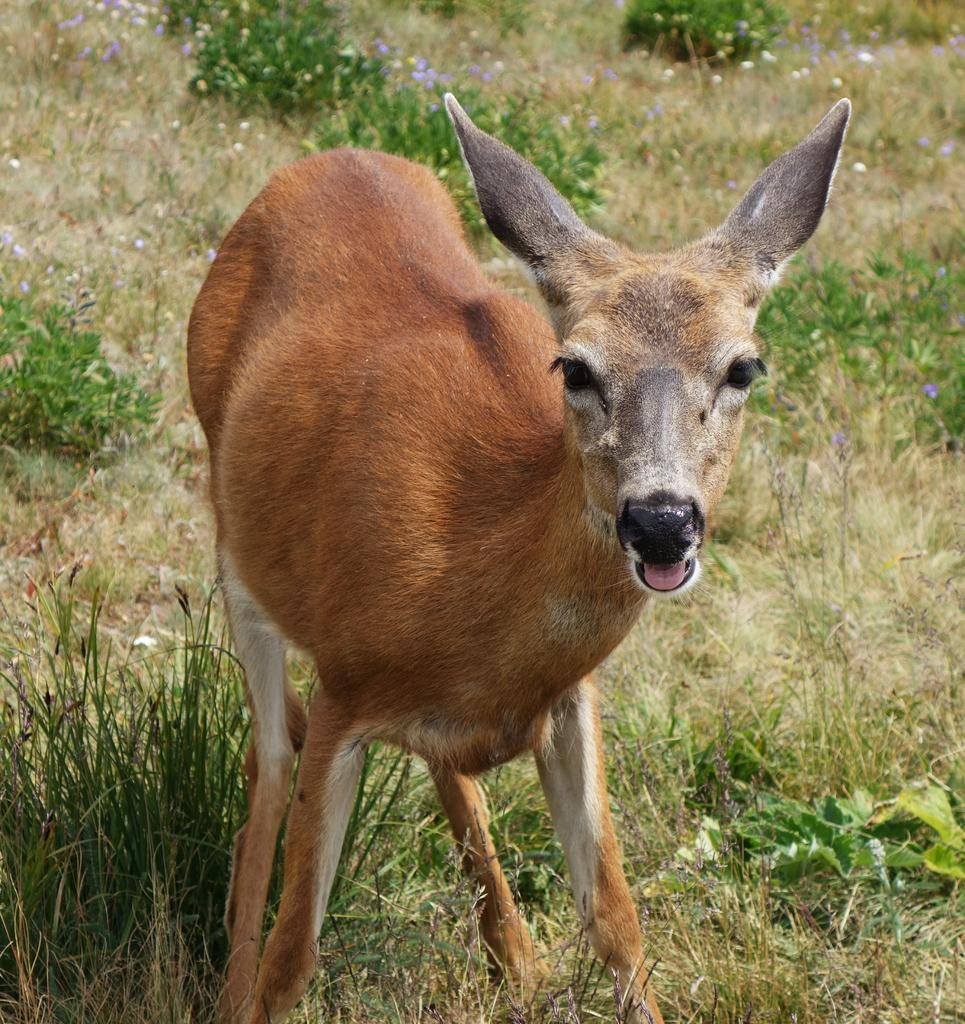What animal is in the foreground of the image? There is a deer in the foreground of the image. What type of environment is the deer in? The deer is on a grassland. What can be seen in the background of the image? There are small flower plants and the grassland visible in the background. What type of leather is being used to make the books in the image? There are no books or leather present in the image; it features a deer on a grassland with small flower plants in the background. 